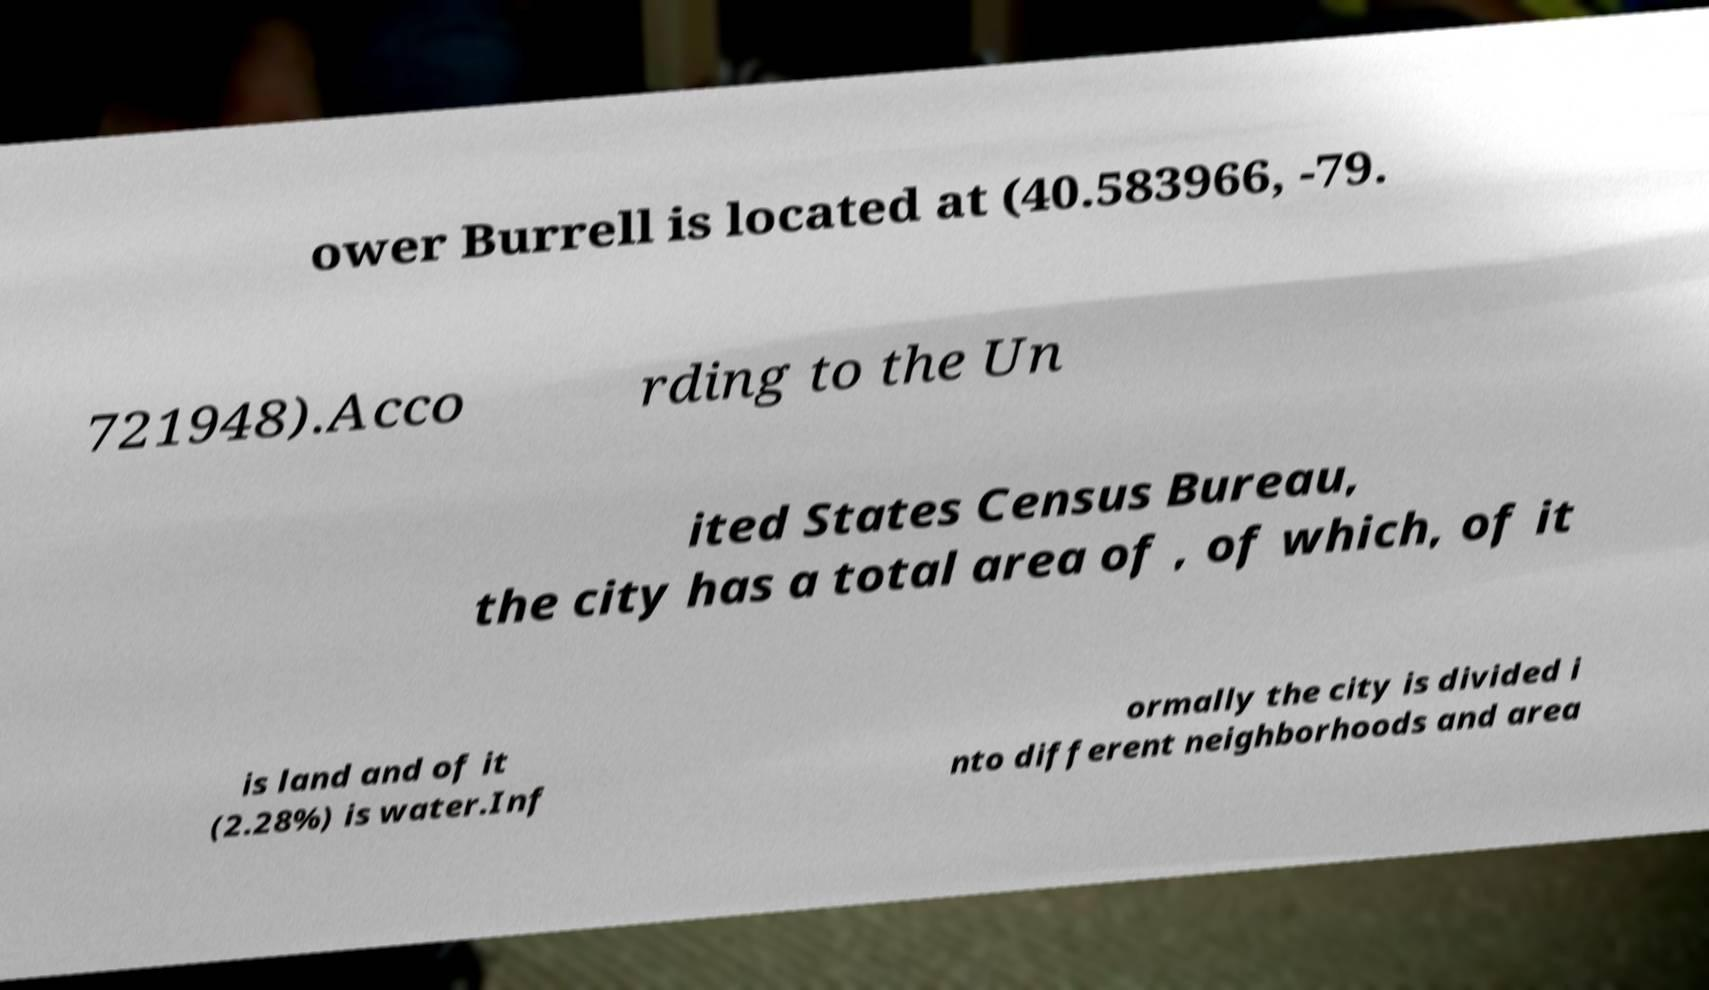Could you assist in decoding the text presented in this image and type it out clearly? ower Burrell is located at (40.583966, -79. 721948).Acco rding to the Un ited States Census Bureau, the city has a total area of , of which, of it is land and of it (2.28%) is water.Inf ormally the city is divided i nto different neighborhoods and area 